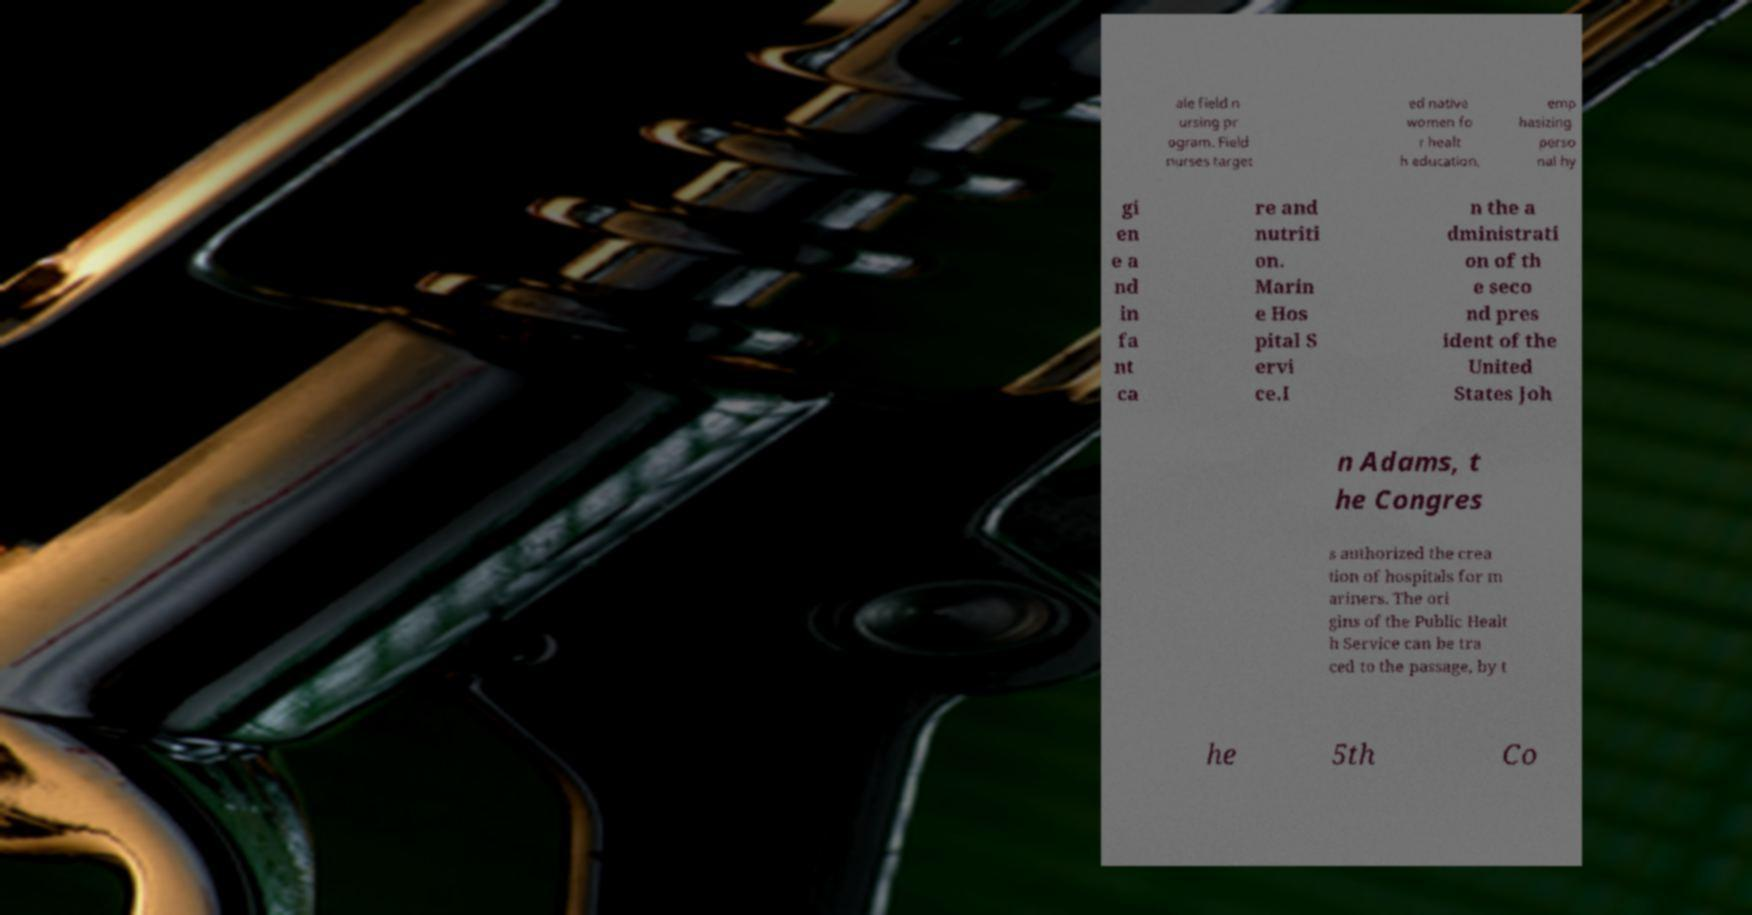There's text embedded in this image that I need extracted. Can you transcribe it verbatim? ale field n ursing pr ogram. Field nurses target ed native women fo r healt h education, emp hasizing perso nal hy gi en e a nd in fa nt ca re and nutriti on. Marin e Hos pital S ervi ce.I n the a dministrati on of th e seco nd pres ident of the United States Joh n Adams, t he Congres s authorized the crea tion of hospitals for m ariners. The ori gins of the Public Healt h Service can be tra ced to the passage, by t he 5th Co 